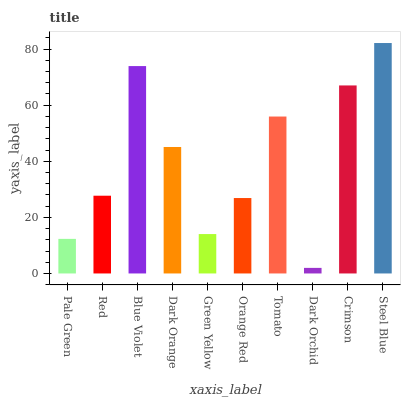Is Dark Orchid the minimum?
Answer yes or no. Yes. Is Steel Blue the maximum?
Answer yes or no. Yes. Is Red the minimum?
Answer yes or no. No. Is Red the maximum?
Answer yes or no. No. Is Red greater than Pale Green?
Answer yes or no. Yes. Is Pale Green less than Red?
Answer yes or no. Yes. Is Pale Green greater than Red?
Answer yes or no. No. Is Red less than Pale Green?
Answer yes or no. No. Is Dark Orange the high median?
Answer yes or no. Yes. Is Red the low median?
Answer yes or no. Yes. Is Blue Violet the high median?
Answer yes or no. No. Is Green Yellow the low median?
Answer yes or no. No. 